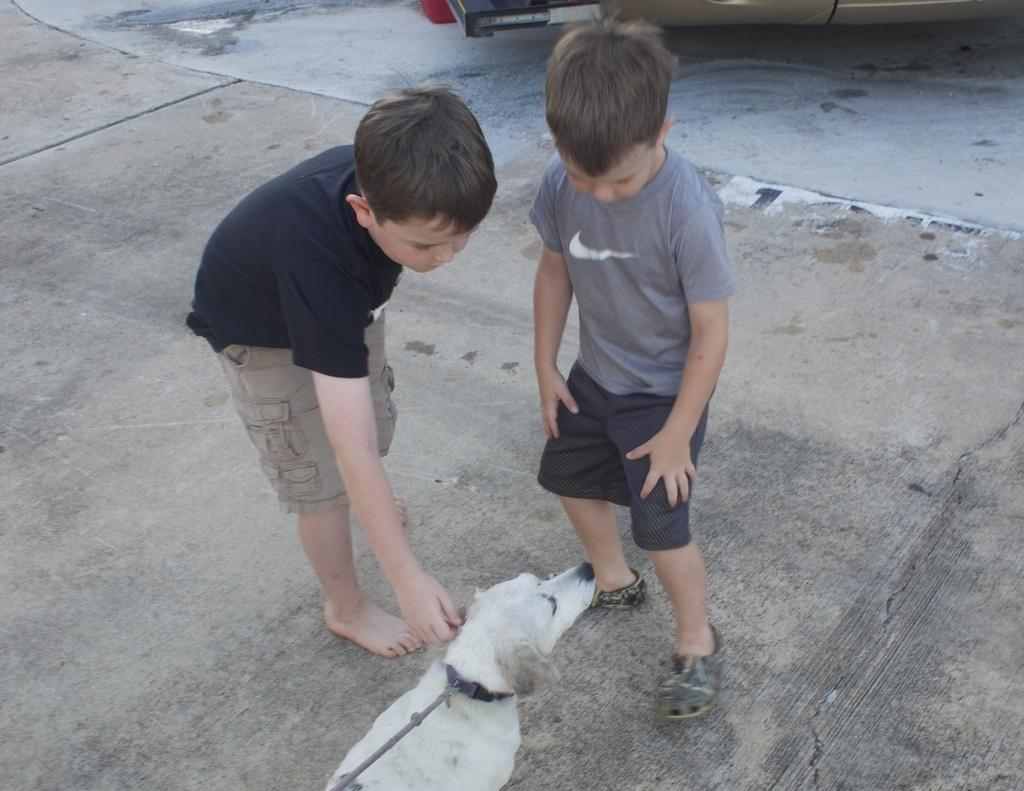How many kids are in the image? There are two kids standing in the center of the image. What is located at the bottom of the image? There is a dog at the bottom of the image. Where is the needle in the image? There is no needle present in the image. What type of pest can be seen interacting with the kids in the image? There are no pests visible in the image; only the kids and the dog are present. 